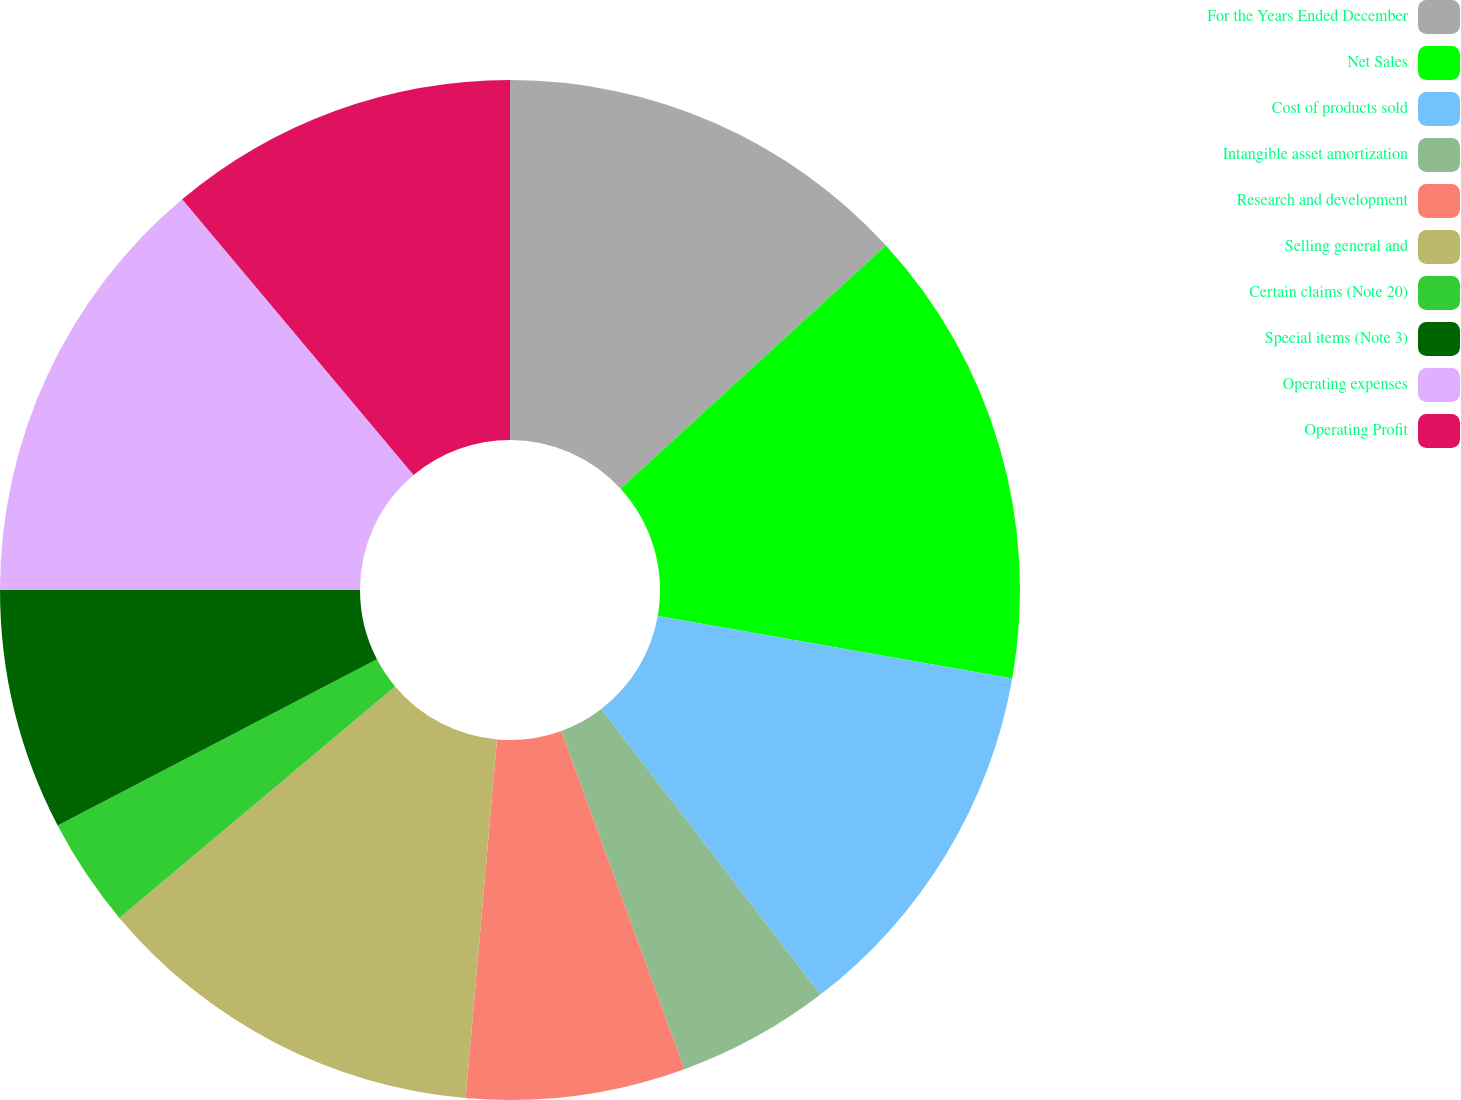Convert chart. <chart><loc_0><loc_0><loc_500><loc_500><pie_chart><fcel>For the Years Ended December<fcel>Net Sales<fcel>Cost of products sold<fcel>Intangible asset amortization<fcel>Research and development<fcel>Selling general and<fcel>Certain claims (Note 20)<fcel>Special items (Note 3)<fcel>Operating expenses<fcel>Operating Profit<nl><fcel>13.19%<fcel>14.58%<fcel>11.81%<fcel>4.86%<fcel>6.94%<fcel>12.5%<fcel>3.47%<fcel>7.64%<fcel>13.89%<fcel>11.11%<nl></chart> 